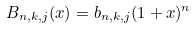Convert formula to latex. <formula><loc_0><loc_0><loc_500><loc_500>B _ { n , k , j } ( x ) = b _ { n , k , j } ( 1 + x ) ^ { n }</formula> 